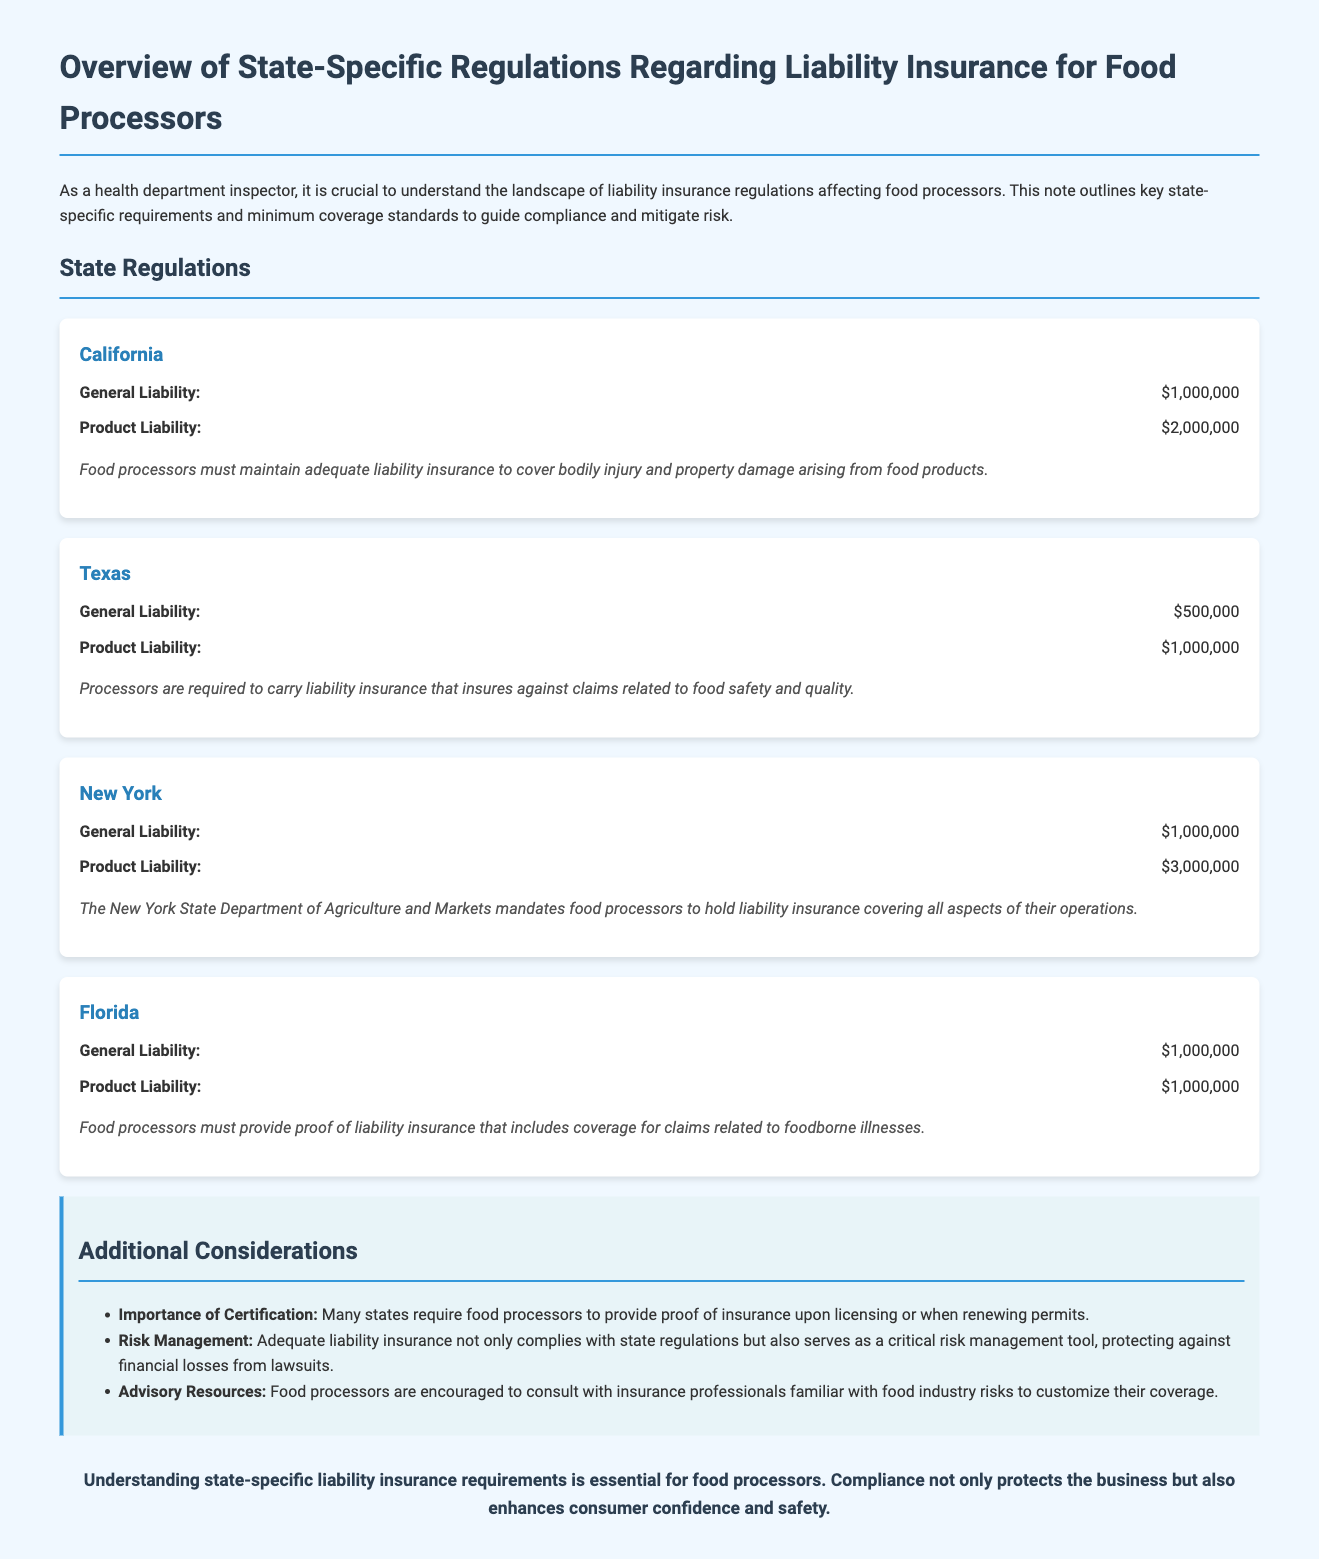What is the general liability coverage for California? The document states that the general liability coverage for California is $1,000,000.
Answer: $1,000,000 What is the product liability coverage required in New York? According to the document, the product liability coverage required in New York is $3,000,000.
Answer: $3,000,000 Which state requires a minimum product liability coverage of $1,000,000? The document lists Florida as a state requiring a minimum product liability coverage of $1,000,000.
Answer: Florida What additional consideration emphasizes the importance of proof of insurance? The document notes that many states require food processors to provide proof of insurance upon licensing or when renewing permits.
Answer: Importance of Certification Which state's regulations include coverage for foodborne illnesses? The document mentions that Florida mandates coverage for claims related to foodborne illnesses.
Answer: Florida What is the minimum general liability coverage in Texas? The minimum general liability coverage in Texas according to the document is $500,000.
Answer: $500,000 What is a key risk management tool mentioned in the document? The document references that adequate liability insurance serves as a critical risk management tool.
Answer: Risk Management What department mandates liability insurance for New York food processors? The document states that the New York State Department of Agriculture and Markets mandates liability insurance.
Answer: New York State Department of Agriculture and Markets What section outlines state-specific regulations? The section titled "State Regulations" outlines the state-specific regulations regarding liability insurance.
Answer: State Regulations 